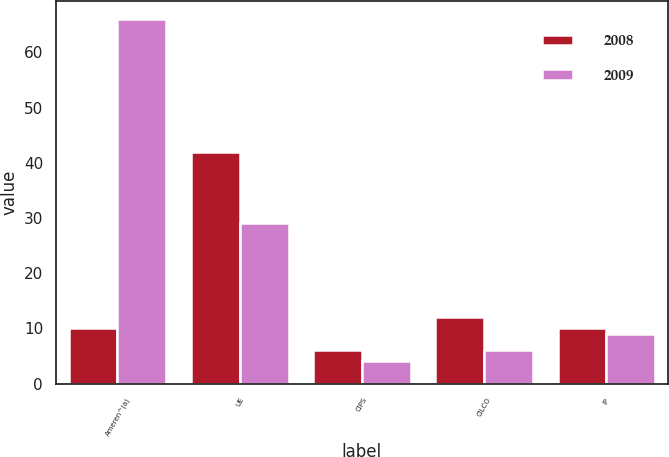Convert chart. <chart><loc_0><loc_0><loc_500><loc_500><stacked_bar_chart><ecel><fcel>Ameren^(a)<fcel>UE<fcel>CIPS<fcel>CILCO<fcel>IP<nl><fcel>2008<fcel>10<fcel>42<fcel>6<fcel>12<fcel>10<nl><fcel>2009<fcel>66<fcel>29<fcel>4<fcel>6<fcel>9<nl></chart> 